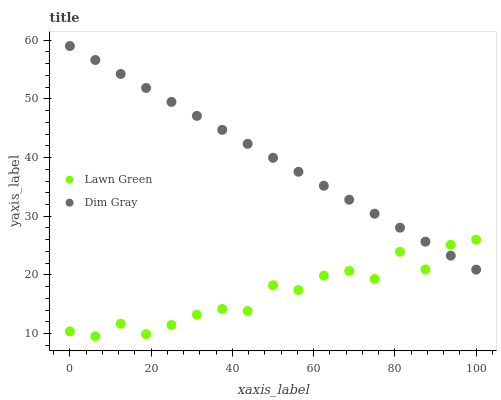Does Lawn Green have the minimum area under the curve?
Answer yes or no. Yes. Does Dim Gray have the maximum area under the curve?
Answer yes or no. Yes. Does Dim Gray have the minimum area under the curve?
Answer yes or no. No. Is Dim Gray the smoothest?
Answer yes or no. Yes. Is Lawn Green the roughest?
Answer yes or no. Yes. Is Dim Gray the roughest?
Answer yes or no. No. Does Lawn Green have the lowest value?
Answer yes or no. Yes. Does Dim Gray have the lowest value?
Answer yes or no. No. Does Dim Gray have the highest value?
Answer yes or no. Yes. Does Dim Gray intersect Lawn Green?
Answer yes or no. Yes. Is Dim Gray less than Lawn Green?
Answer yes or no. No. Is Dim Gray greater than Lawn Green?
Answer yes or no. No. 